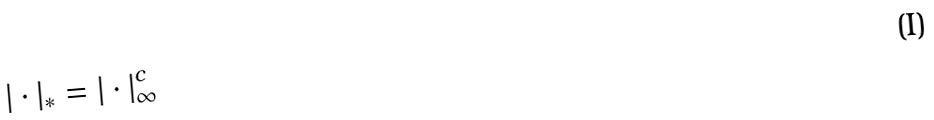Convert formula to latex. <formula><loc_0><loc_0><loc_500><loc_500>| \cdot | _ { * } = | \cdot | _ { \infty } ^ { c }</formula> 